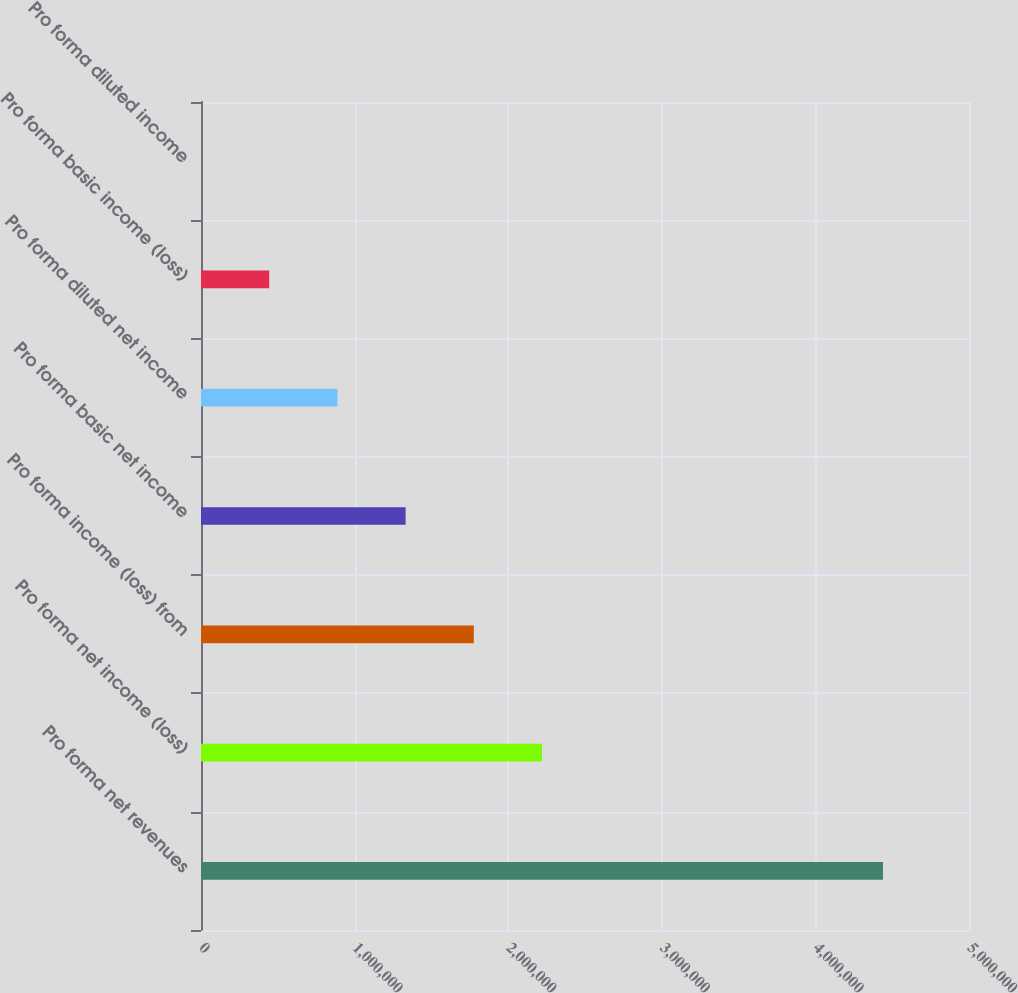Convert chart. <chart><loc_0><loc_0><loc_500><loc_500><bar_chart><fcel>Pro forma net revenues<fcel>Pro forma net income (loss)<fcel>Pro forma income (loss) from<fcel>Pro forma basic net income<fcel>Pro forma diluted net income<fcel>Pro forma basic income (loss)<fcel>Pro forma diluted income<nl><fcel>4.4402e+06<fcel>2.2201e+06<fcel>1.77608e+06<fcel>1.33206e+06<fcel>888042<fcel>444022<fcel>2.33<nl></chart> 